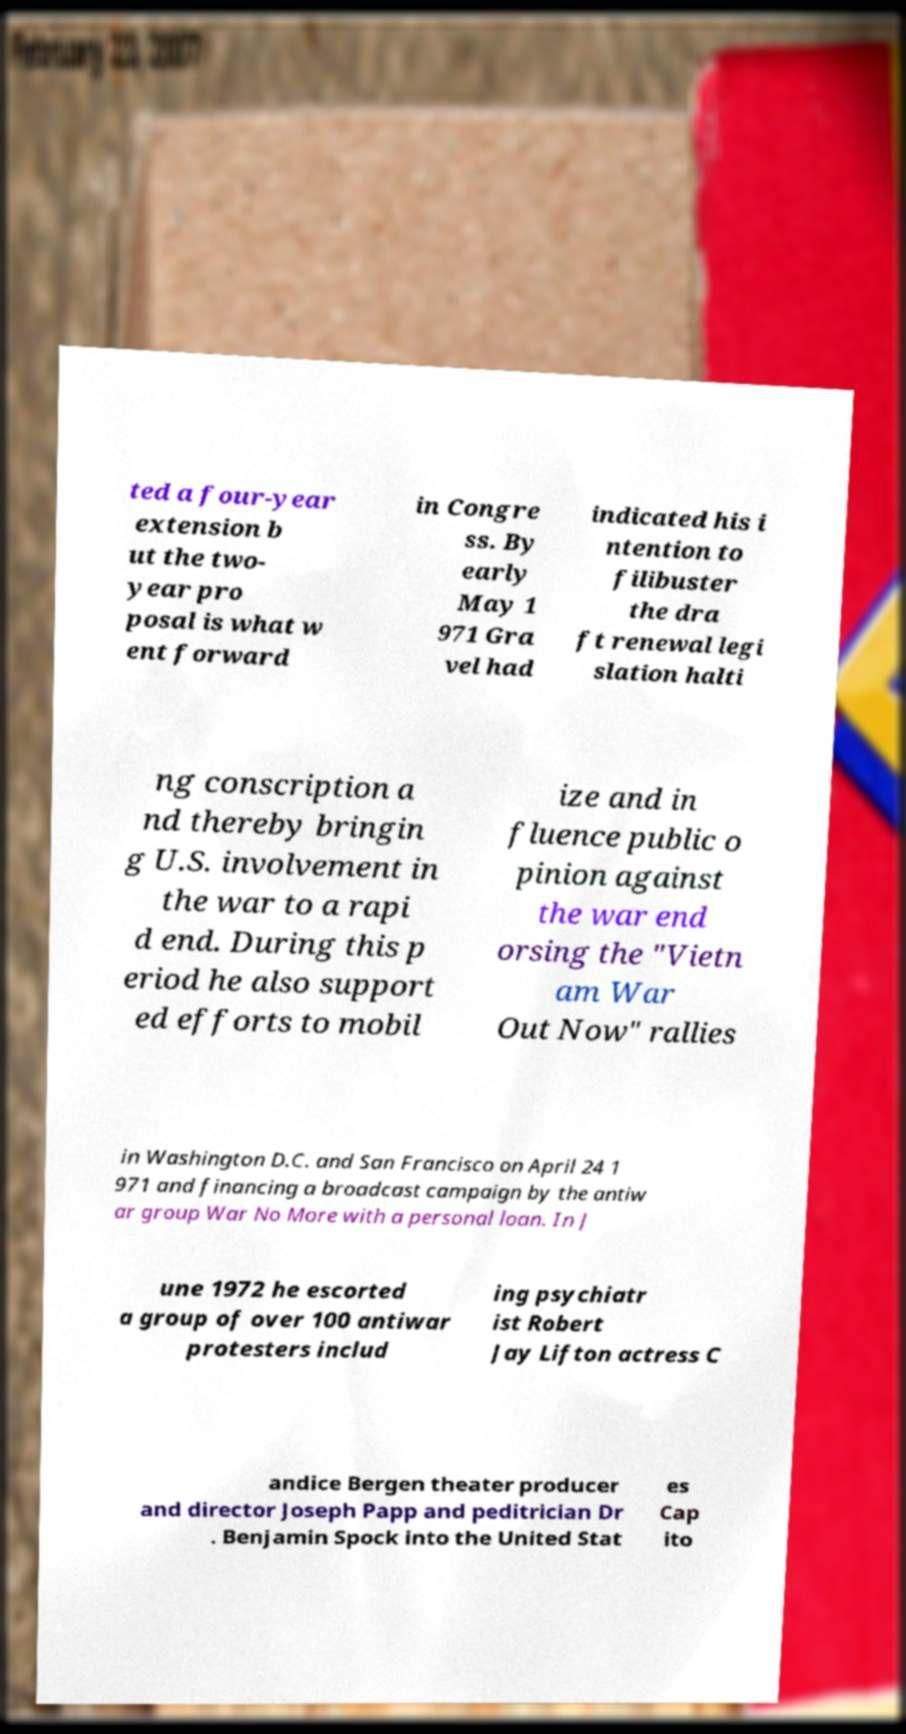Please identify and transcribe the text found in this image. ted a four-year extension b ut the two- year pro posal is what w ent forward in Congre ss. By early May 1 971 Gra vel had indicated his i ntention to filibuster the dra ft renewal legi slation halti ng conscription a nd thereby bringin g U.S. involvement in the war to a rapi d end. During this p eriod he also support ed efforts to mobil ize and in fluence public o pinion against the war end orsing the "Vietn am War Out Now" rallies in Washington D.C. and San Francisco on April 24 1 971 and financing a broadcast campaign by the antiw ar group War No More with a personal loan. In J une 1972 he escorted a group of over 100 antiwar protesters includ ing psychiatr ist Robert Jay Lifton actress C andice Bergen theater producer and director Joseph Papp and peditrician Dr . Benjamin Spock into the United Stat es Cap ito 